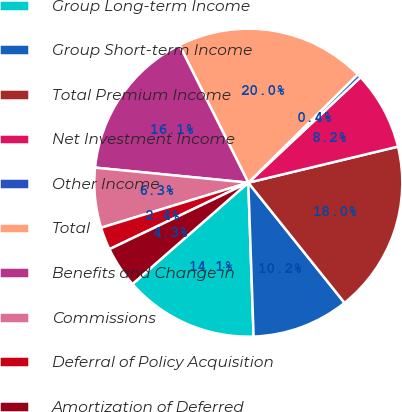Convert chart. <chart><loc_0><loc_0><loc_500><loc_500><pie_chart><fcel>Group Long-term Income<fcel>Group Short-term Income<fcel>Total Premium Income<fcel>Net Investment Income<fcel>Other Income<fcel>Total<fcel>Benefits and Change in<fcel>Commissions<fcel>Deferral of Policy Acquisition<fcel>Amortization of Deferred<nl><fcel>14.11%<fcel>10.2%<fcel>18.02%<fcel>8.24%<fcel>0.42%<fcel>19.97%<fcel>16.06%<fcel>6.29%<fcel>2.38%<fcel>4.33%<nl></chart> 